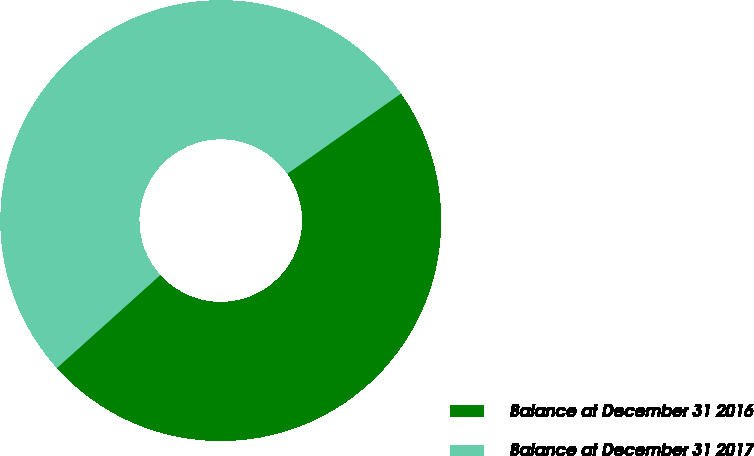<chart> <loc_0><loc_0><loc_500><loc_500><pie_chart><fcel>Balance at December 31 2016<fcel>Balance at December 31 2017<nl><fcel>48.12%<fcel>51.88%<nl></chart> 